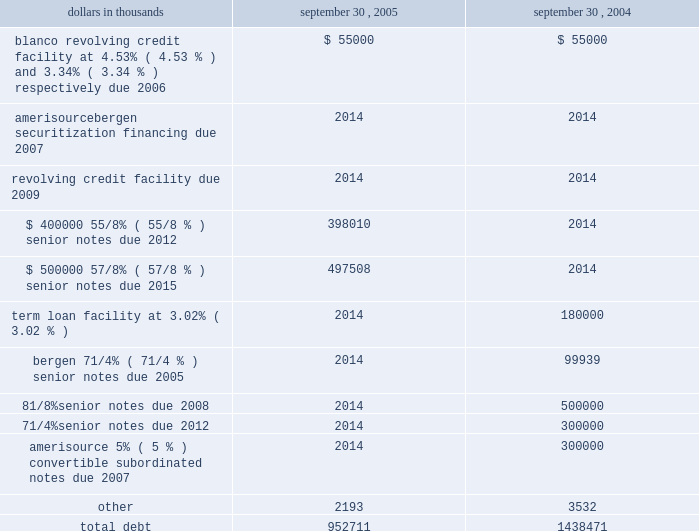Amerisourcebergen corporation 2005 during the fiscal year september 30 , 2005 , the company recorded an impairment charge of $ 5.3 million relating to certain intangible assets within its technology operations .
Amortization expense for other intangible assets was $ 10.3 million , $ 10.0 million and $ 7.0 million in the fiscal years ended september 30 , 2005 , 2004 and 2003 , respectively .
Amortization expense for other intangible assets is estimated to be $ 10.1 million in fiscal 2006 , $ 8.8 million in fiscal 2007 , $ 5.0 million in fiscal 2008 , $ 3.3 million in fiscal 2009 , $ 3.2 million in fiscal 2010 , and $ 15.9 million thereafter .
Note 6 .
Debt debt consisted of the following: .
Long-term debt in september 2005 , the company issued $ 400 million of 5.625% ( 5.625 % ) senior notes due september 15 , 2012 ( the 201c2012 notes 201d ) and $ 500 million of 5.875% ( 5.875 % ) senior notes due september 15 , 2015 ( the 201c2015 notes 201d ) .
The 2012 notes and 2015 notes each were sold at 99.5% ( 99.5 % ) of principal amount and have an effective interest yield of 5.71% ( 5.71 % ) and 5.94% ( 5.94 % ) , respectively .
Interest on the 2012 notes and the 2015 notes is payable semiannually in arrears , commencing on march 15 , 2006 .
Both the 2012 notes and the 2015 notes are redeemable at the company 2019s option at a price equal to the greater of 100% ( 100 % ) of the principal amount thereof , or the sum of the discounted value of the remaining scheduled payments , as defined .
In addition , at any time before september 15 , 2008 , the company may redeem up to an aggregate of 35% ( 35 % ) of the principal amount of the 2012 notes or the 2015 notes at redemption prices equal to 105.625% ( 105.625 % ) and 105.875% ( 105.875 % ) , respectively , of the principal amounts thereof , plus accrued and unpaid interest and liquidated damages , if any , to the date of redemption , with the cash proceeds of one or more equity issuances .
In connection with the issuance of the 2012 notes and the 2015 notes , the company incurred approximately $ 6.3 million and $ 7.9 million of costs , respectively , which were deferred and are being amortized over the terms of the notes .
The gross proceeds from the sale of the 2012 notes and the 2015 notes were used to finance the early retirement of the $ 500 million of 81 20448% ( 20448 % ) senior notes due 2008 and $ 300 million of 71 20444% ( 20444 % ) senior notes due 2012 in september 2005 , including the payment of $ 102.3 million of premiums and other costs .
Additionally , the company expensed $ 8.5 million of deferred financing costs related to the retirement of the 71 20444% ( 20444 % ) notes and the 81 20448% ( 20448 % ) notes .
In december 2004 , the company entered into a $ 700 million five-year senior unsecured revolving credit facility ( the 201csenior revolving credit facility 201d ) with a syndicate of lenders .
The senior revolving credit facility replaced the senior credit agreement , as defined below .
There were no borrowings outstanding under the senior revolving credit facility at september 30 , 2005 .
Interest on borrowings under the senior revolving credit facility accrues at specific rates based on the company 2019s debt rating .
In april 2005 , the company 2019s debt rating was raised by one of the rating agencies and in accordance with the terms of the senior revolving credit facility , interest on borrow- ings accrue at either 80 basis points over libor or the prime rate at september 30 , 2005 .
Availability under the senior revolving credit facility is reduced by the amount of outstanding letters of credit ( $ 12.0 million at september 30 , 2005 ) .
The company pays quarterly facility fees to maintain the availability under the senior revolving credit facility at specific rates based on the company 2019s debt rating .
In april 2005 , the rate payable to maintain the availability of the $ 700 million commitment was reduced to 20 basis points per annum resulting from the company 2019s improved debt rating .
In connection with entering into the senior revolving credit facility , the company incurred approximately $ 2.5 million of costs , which were deferred and are being amortized over the life of the facility .
The company may choose to repay or reduce its commitments under the senior revolving credit facility at any time .
The senior revolving credit facility contains covenants that impose limitations on , among other things , additional indebtedness , distributions and dividends to stockholders , and invest- ments .
Additional covenants require compliance with financial tests , including leverage and minimum earnings to fixed charges ratios .
In august 2001 , the company had entered into a senior secured credit agreement ( the 201csenior credit agreement 201d ) with a syndicate of lenders .
The senior credit agreement consisted of a $ 1.0 billion revolving credit facility ( the 201crevolving facility 201d ) and a $ 300 million term loan facility ( the 201cterm facility 201d ) , both of which had been scheduled to mature in august 2006 .
The term facility had scheduled quarterly maturities , which began in december 2002 , totaling $ 60 million in each of fiscal 2003 and 2004 , $ 80 million in fiscal 2005 and $ 100 million in fiscal 2006 .
The company previously paid the scheduled quarterly maturities of $ 60 million in fiscal 2004 and 2003. .
What was the change in total debt net of current portions in thousands between 2004 and 2005? 
Computations: (951479 - 1157111)
Answer: -205632.0. 